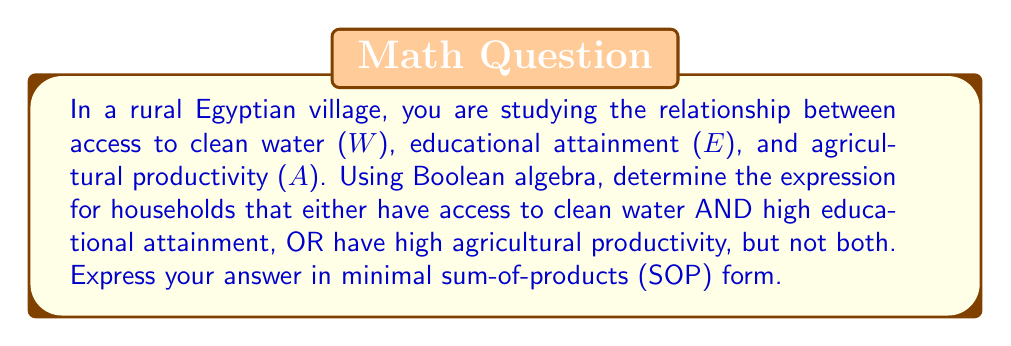Can you solve this math problem? Let's approach this step-by-step:

1) First, let's define our Boolean variables:
   W: Access to clean water
   E: High educational attainment
   A: High agricultural productivity

2) The question asks for households that have either:
   (W AND E) OR A, but not both

3) We can express this using the XOR operation (⊕):
   $$(W \cdot E) \oplus A$$

4) Expanding the XOR operation:
   $$(W \cdot E) \oplus A = (W \cdot E \cdot \overline{A}) + (\overline{W \cdot E} \cdot A)$$

5) Simplify $\overline{W \cdot E}$ using De Morgan's law:
   $$(W \cdot E \cdot \overline{A}) + ((\overline{W} + \overline{E}) \cdot A)$$

6) Distribute A:
   $$(W \cdot E \cdot \overline{A}) + (\overline{W} \cdot A + \overline{E} \cdot A)$$

7) This is already in sum-of-products (SOP) form, and it's minimal as no further reduction is possible.
Answer: $$(W \cdot E \cdot \overline{A}) + (\overline{W} \cdot A) + (\overline{E} \cdot A)$$ 